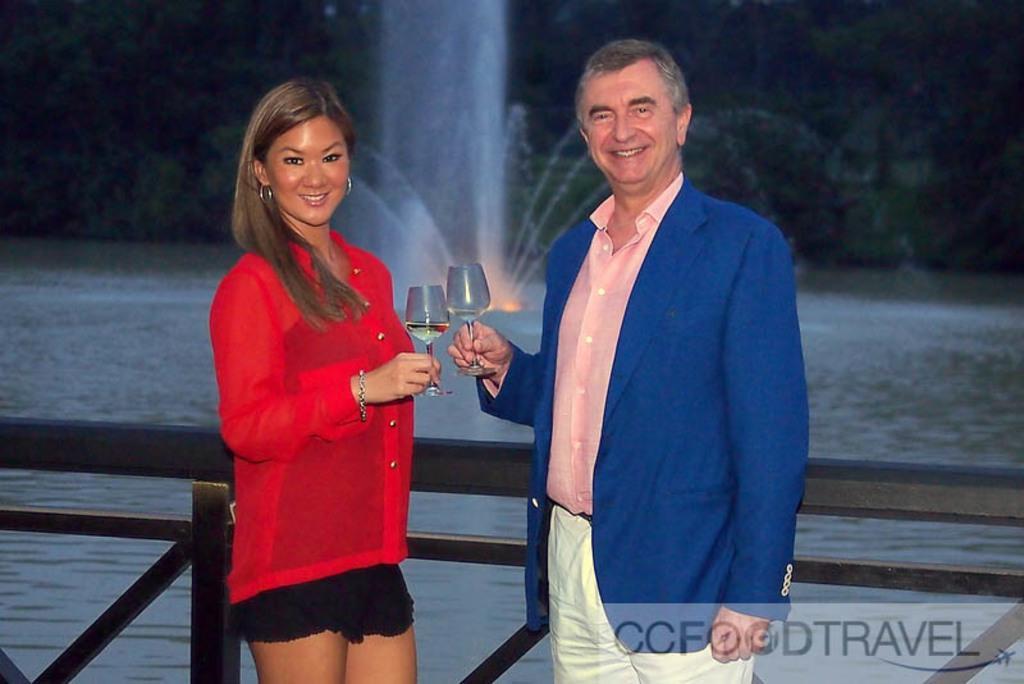Can you describe this image briefly? In this image we can see a man and a woman standing and holding the glasses and smiling. We can also see the fence and behind the fence we can see the water and also trees. At the bottom there is watermark. 